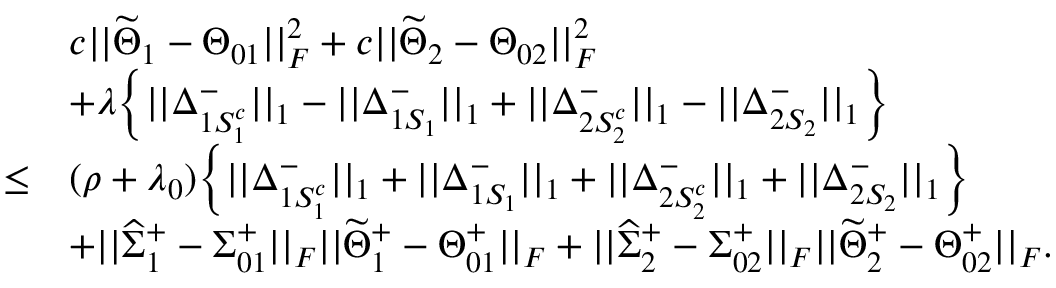<formula> <loc_0><loc_0><loc_500><loc_500>\begin{array} { r l } & { c | | \widetilde { \Theta } _ { 1 } - \Theta _ { 0 1 } | | _ { F } ^ { 2 } + c | | \widetilde { \Theta } _ { 2 } - \Theta _ { 0 2 } | | _ { F } ^ { 2 } } \\ & { + \lambda \left \{ | | \Delta _ { 1 S _ { 1 } ^ { c } } ^ { - } | | _ { 1 } - | | \Delta _ { 1 S _ { 1 } } ^ { - } | | _ { 1 } + | | \Delta _ { 2 S _ { 2 } ^ { c } } ^ { - } | | _ { 1 } - | | \Delta _ { 2 S _ { 2 } } ^ { - } | | _ { 1 } \right \} } \\ { \leq } & { ( \rho + \lambda _ { 0 } ) \left \{ | | \Delta _ { 1 S _ { 1 } ^ { c } } ^ { - } | | _ { 1 } + | | \Delta _ { 1 S _ { 1 } } ^ { - } | | _ { 1 } + | | \Delta _ { 2 S _ { 2 } ^ { c } } ^ { - } | | _ { 1 } + | | \Delta _ { 2 S _ { 2 } } ^ { - } | | _ { 1 } \right \} } \\ & { + | | \widehat { \Sigma } _ { 1 } ^ { + } - \Sigma _ { 0 1 } ^ { + } | | _ { F } | | \widetilde { \Theta } _ { 1 } ^ { + } - \Theta _ { 0 1 } ^ { + } | | _ { F } + | | \widehat { \Sigma } _ { 2 } ^ { + } - \Sigma _ { 0 2 } ^ { + } | | _ { F } | | \widetilde { \Theta } _ { 2 } ^ { + } - \Theta _ { 0 2 } ^ { + } | | _ { F } . } \end{array}</formula> 